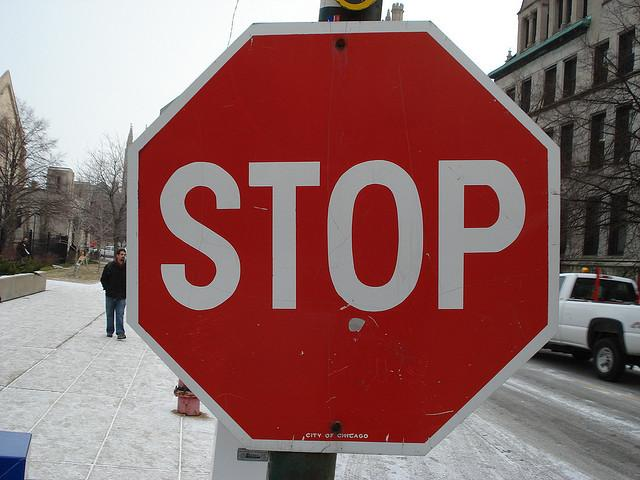This city's name comes from a Native American word for what? onion 